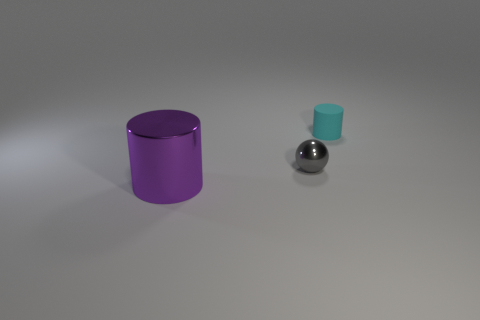Is there anything else that is the same material as the small cyan object?
Your response must be concise. No. Are there an equal number of cylinders that are to the right of the small cyan thing and gray metal balls?
Your response must be concise. No. Is there a small cyan thing of the same shape as the purple shiny thing?
Your answer should be compact. Yes. There is a thing that is left of the cyan rubber object and right of the big shiny cylinder; what shape is it?
Offer a very short reply. Sphere. Do the cyan object and the object in front of the ball have the same material?
Offer a very short reply. No. Are there any cyan things on the left side of the gray ball?
Keep it short and to the point. No. What number of objects are big purple objects or small spheres in front of the matte cylinder?
Your response must be concise. 2. There is a metal object to the left of the metal thing that is right of the large metal object; what is its color?
Ensure brevity in your answer.  Purple. How many other objects are the same material as the small gray object?
Make the answer very short. 1. How many rubber objects are large purple things or yellow cylinders?
Ensure brevity in your answer.  0. 